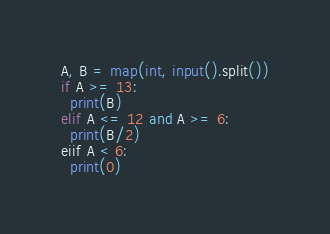<code> <loc_0><loc_0><loc_500><loc_500><_Python_>A, B = map(int, input().split())
if A >= 13:
  print(B)
elif A <= 12 and A >= 6:
  print(B/2)
eiif A < 6:
  print(0) </code> 